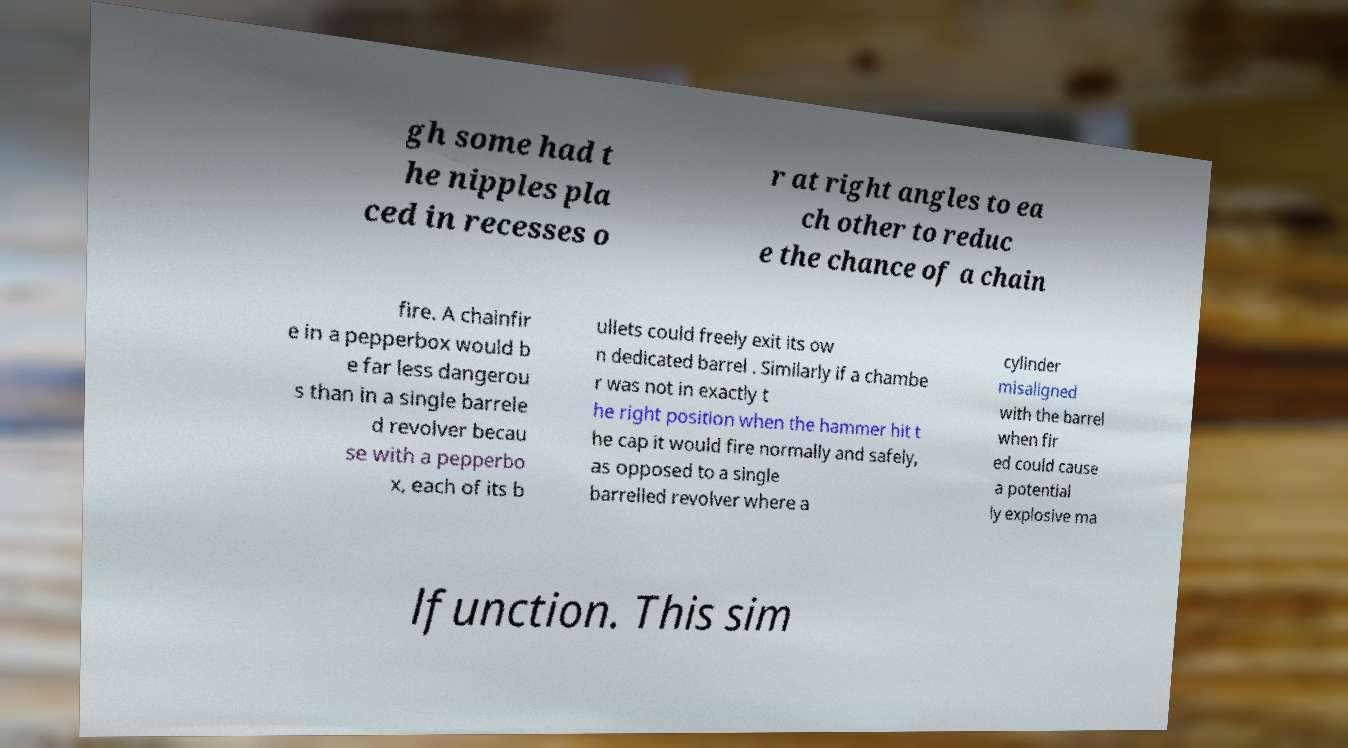I need the written content from this picture converted into text. Can you do that? gh some had t he nipples pla ced in recesses o r at right angles to ea ch other to reduc e the chance of a chain fire. A chainfir e in a pepperbox would b e far less dangerou s than in a single barrele d revolver becau se with a pepperbo x, each of its b ullets could freely exit its ow n dedicated barrel . Similarly if a chambe r was not in exactly t he right position when the hammer hit t he cap it would fire normally and safely, as opposed to a single barrelled revolver where a cylinder misaligned with the barrel when fir ed could cause a potential ly explosive ma lfunction. This sim 